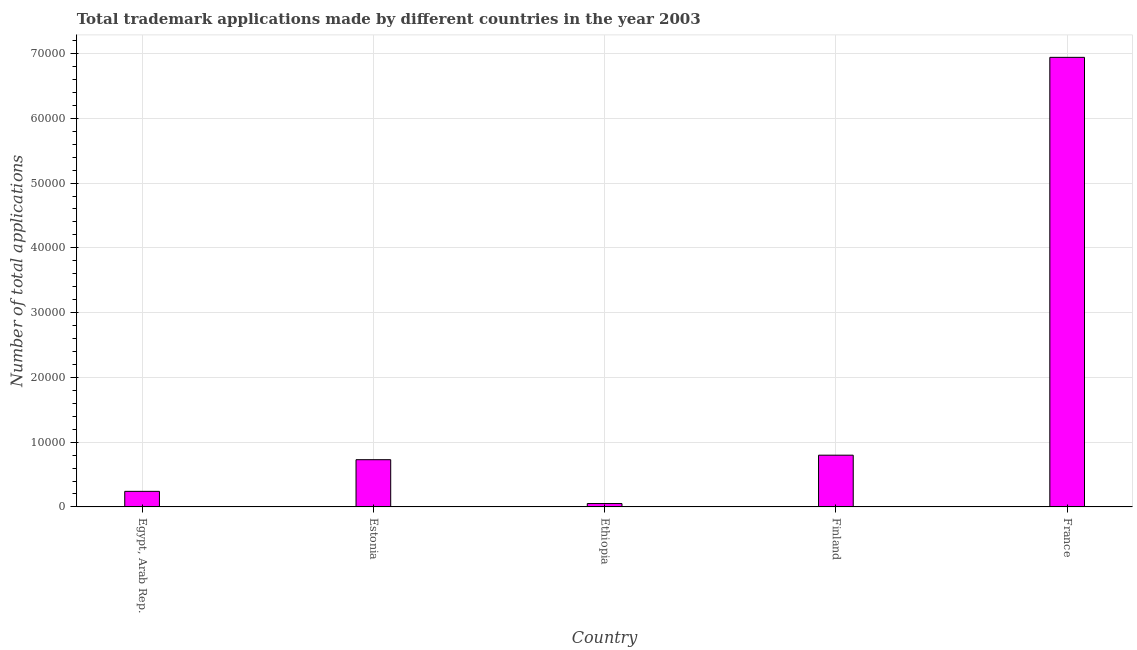Does the graph contain grids?
Keep it short and to the point. Yes. What is the title of the graph?
Your answer should be very brief. Total trademark applications made by different countries in the year 2003. What is the label or title of the X-axis?
Your response must be concise. Country. What is the label or title of the Y-axis?
Your answer should be very brief. Number of total applications. What is the number of trademark applications in Egypt, Arab Rep.?
Your response must be concise. 2404. Across all countries, what is the maximum number of trademark applications?
Offer a terse response. 6.94e+04. Across all countries, what is the minimum number of trademark applications?
Give a very brief answer. 520. In which country was the number of trademark applications maximum?
Your response must be concise. France. In which country was the number of trademark applications minimum?
Give a very brief answer. Ethiopia. What is the sum of the number of trademark applications?
Offer a terse response. 8.76e+04. What is the difference between the number of trademark applications in Estonia and France?
Make the answer very short. -6.21e+04. What is the average number of trademark applications per country?
Provide a succinct answer. 1.75e+04. What is the median number of trademark applications?
Your answer should be very brief. 7292. What is the ratio of the number of trademark applications in Egypt, Arab Rep. to that in France?
Your answer should be very brief. 0.04. What is the difference between the highest and the second highest number of trademark applications?
Offer a terse response. 6.14e+04. What is the difference between the highest and the lowest number of trademark applications?
Offer a terse response. 6.89e+04. In how many countries, is the number of trademark applications greater than the average number of trademark applications taken over all countries?
Keep it short and to the point. 1. How many bars are there?
Offer a very short reply. 5. Are all the bars in the graph horizontal?
Provide a short and direct response. No. How many countries are there in the graph?
Make the answer very short. 5. Are the values on the major ticks of Y-axis written in scientific E-notation?
Your answer should be compact. No. What is the Number of total applications in Egypt, Arab Rep.?
Your answer should be very brief. 2404. What is the Number of total applications of Estonia?
Offer a very short reply. 7292. What is the Number of total applications in Ethiopia?
Ensure brevity in your answer.  520. What is the Number of total applications in Finland?
Your answer should be very brief. 7989. What is the Number of total applications in France?
Offer a terse response. 6.94e+04. What is the difference between the Number of total applications in Egypt, Arab Rep. and Estonia?
Give a very brief answer. -4888. What is the difference between the Number of total applications in Egypt, Arab Rep. and Ethiopia?
Give a very brief answer. 1884. What is the difference between the Number of total applications in Egypt, Arab Rep. and Finland?
Offer a very short reply. -5585. What is the difference between the Number of total applications in Egypt, Arab Rep. and France?
Make the answer very short. -6.70e+04. What is the difference between the Number of total applications in Estonia and Ethiopia?
Your answer should be very brief. 6772. What is the difference between the Number of total applications in Estonia and Finland?
Provide a succinct answer. -697. What is the difference between the Number of total applications in Estonia and France?
Your answer should be very brief. -6.21e+04. What is the difference between the Number of total applications in Ethiopia and Finland?
Your answer should be compact. -7469. What is the difference between the Number of total applications in Ethiopia and France?
Ensure brevity in your answer.  -6.89e+04. What is the difference between the Number of total applications in Finland and France?
Your response must be concise. -6.14e+04. What is the ratio of the Number of total applications in Egypt, Arab Rep. to that in Estonia?
Your answer should be compact. 0.33. What is the ratio of the Number of total applications in Egypt, Arab Rep. to that in Ethiopia?
Provide a short and direct response. 4.62. What is the ratio of the Number of total applications in Egypt, Arab Rep. to that in Finland?
Give a very brief answer. 0.3. What is the ratio of the Number of total applications in Egypt, Arab Rep. to that in France?
Keep it short and to the point. 0.04. What is the ratio of the Number of total applications in Estonia to that in Ethiopia?
Give a very brief answer. 14.02. What is the ratio of the Number of total applications in Estonia to that in France?
Your answer should be very brief. 0.1. What is the ratio of the Number of total applications in Ethiopia to that in Finland?
Provide a short and direct response. 0.07. What is the ratio of the Number of total applications in Ethiopia to that in France?
Your answer should be compact. 0.01. What is the ratio of the Number of total applications in Finland to that in France?
Make the answer very short. 0.12. 